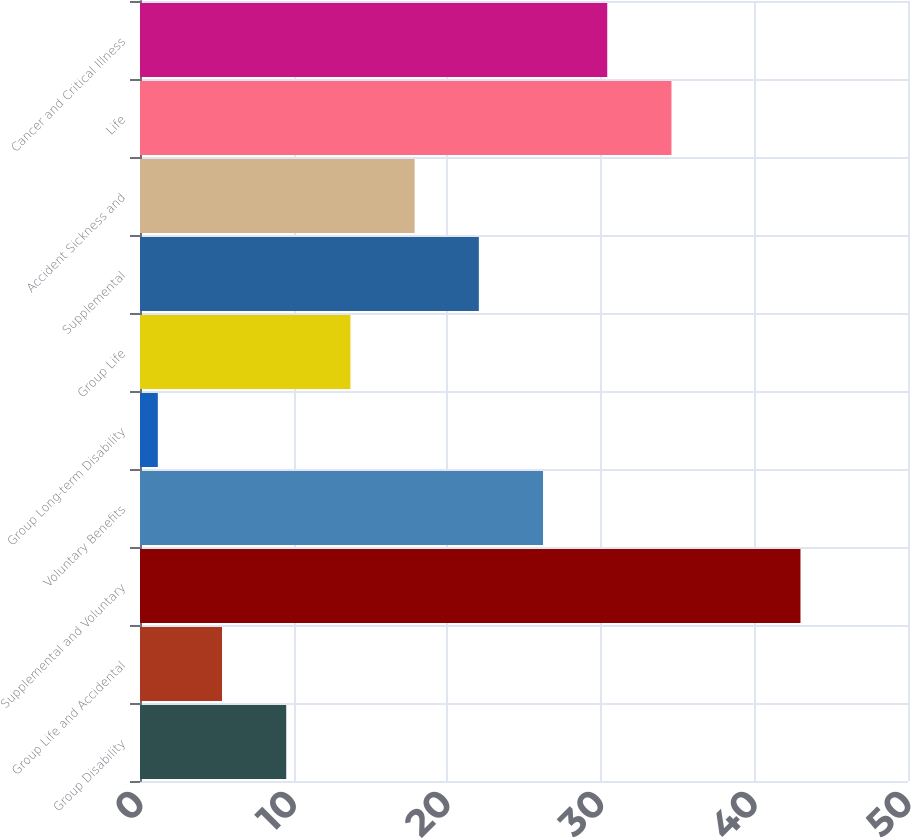Convert chart to OTSL. <chart><loc_0><loc_0><loc_500><loc_500><bar_chart><fcel>Group Disability<fcel>Group Life and Accidental<fcel>Supplemental and Voluntary<fcel>Voluntary Benefits<fcel>Group Long-term Disability<fcel>Group Life<fcel>Supplemental<fcel>Accident Sickness and<fcel>Life<fcel>Cancer and Critical Illness<nl><fcel>9.52<fcel>5.34<fcel>43<fcel>26.24<fcel>1.16<fcel>13.7<fcel>22.06<fcel>17.88<fcel>34.6<fcel>30.42<nl></chart> 